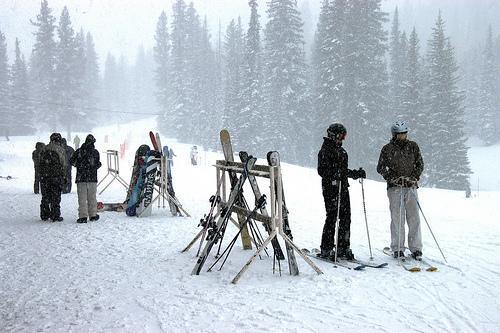How many people are holding ski poles?
Give a very brief answer. 2. 